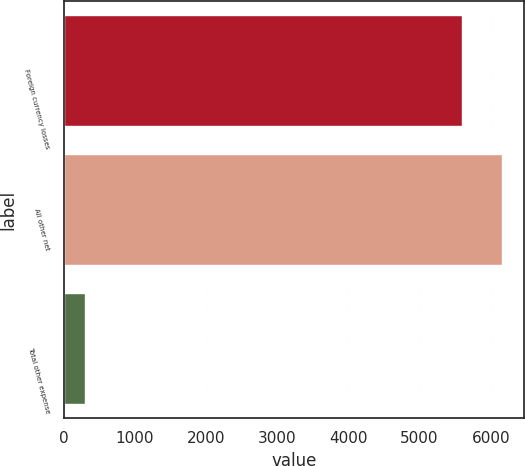<chart> <loc_0><loc_0><loc_500><loc_500><bar_chart><fcel>Foreign currency losses<fcel>All other net<fcel>Total other expense<nl><fcel>5599<fcel>6158.9<fcel>303<nl></chart> 